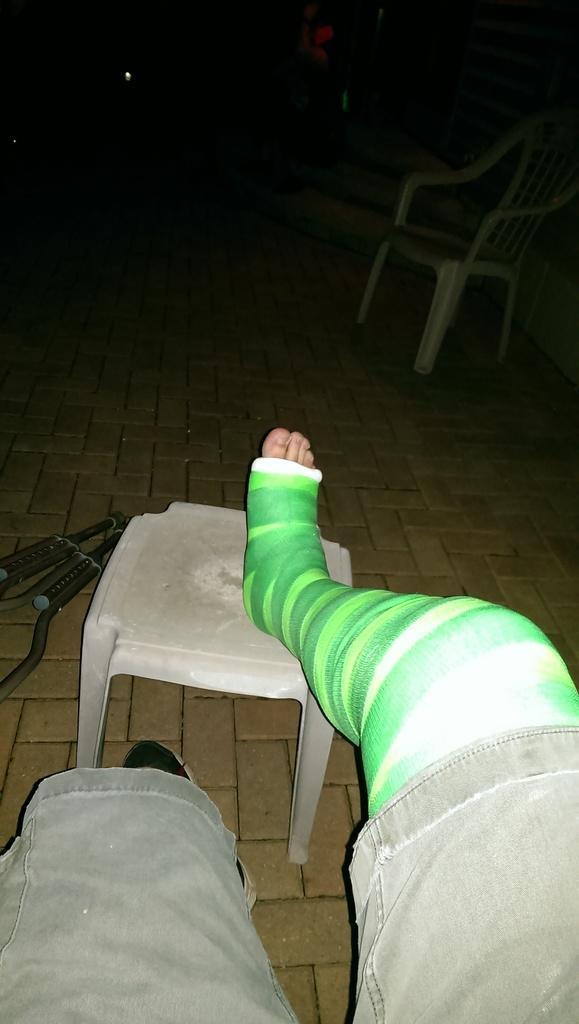How would you summarize this image in a sentence or two? In this picture we can see legs of people, chair and objects on the floor. In the background of the image it is dark and we can see chair. 